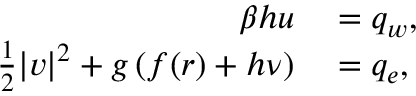<formula> <loc_0><loc_0><loc_500><loc_500>\begin{array} { r l } { \beta h u } & = q _ { w } , } \\ { \frac { 1 } { 2 } | v | ^ { 2 } + g \left ( f ( r ) + h \nu \right ) } & = q _ { e } , } \end{array}</formula> 